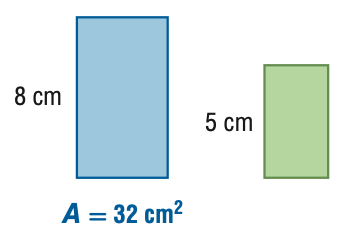Question: For the pair of similar figures, find the area of the green figure.
Choices:
A. 12.5
B. 20.0
C. 51.2
D. 81.9
Answer with the letter. Answer: A 